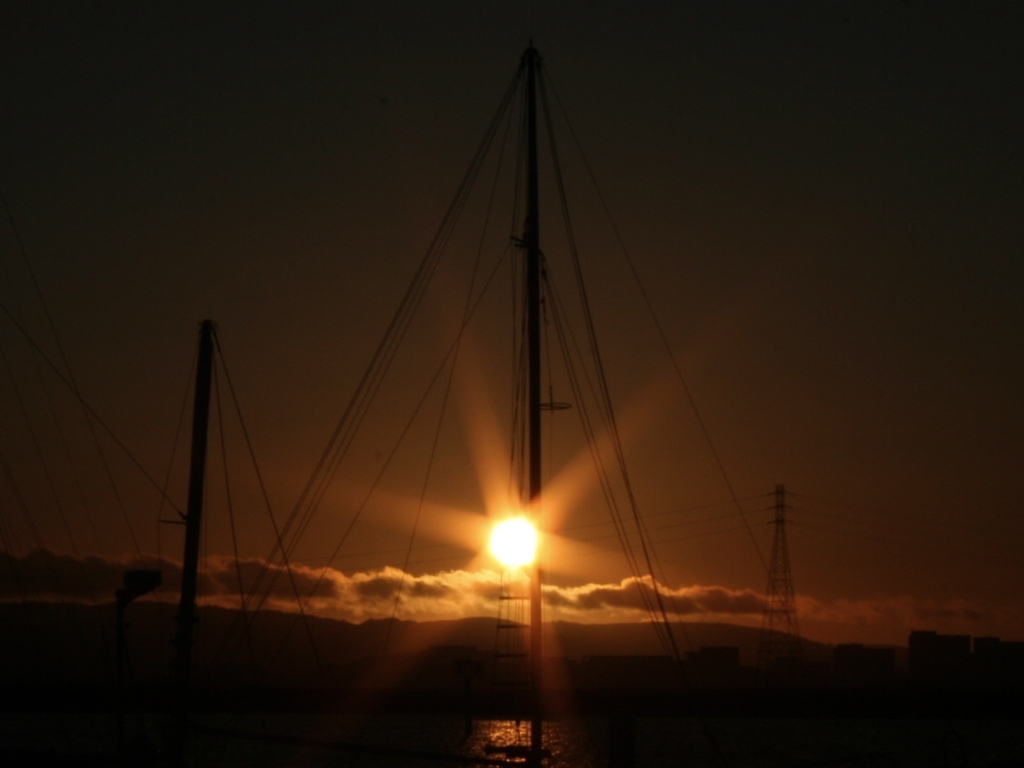What time of day was this photo taken? Considering the position of the sun near the horizon and the color palette of the sky, the photo appears to have been taken during sunset. 